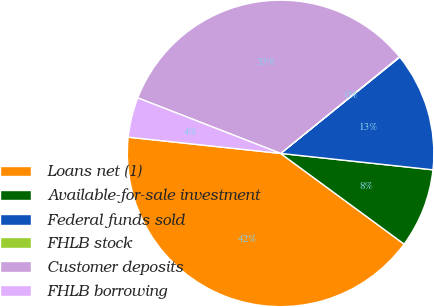<chart> <loc_0><loc_0><loc_500><loc_500><pie_chart><fcel>Loans net (1)<fcel>Available-for-sale investment<fcel>Federal funds sold<fcel>FHLB stock<fcel>Customer deposits<fcel>FHLB borrowing<nl><fcel>41.61%<fcel>8.37%<fcel>12.52%<fcel>0.05%<fcel>33.23%<fcel>4.21%<nl></chart> 